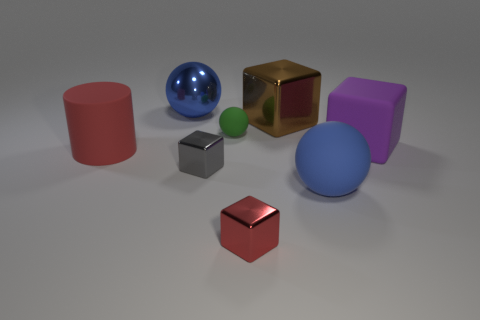Is there any other thing of the same color as the big rubber sphere?
Your response must be concise. Yes. Does the big rubber thing on the left side of the green sphere have the same color as the small thing in front of the blue matte sphere?
Give a very brief answer. Yes. What is the shape of the matte thing that is the same color as the shiny sphere?
Offer a very short reply. Sphere. What number of things are either tiny green cubes or large metal things that are right of the small gray metallic cube?
Offer a terse response. 1. Are there more tiny green rubber things than big brown matte cylinders?
Keep it short and to the point. Yes. There is a big thing on the left side of the large metallic ball; what is its shape?
Your response must be concise. Cylinder. What number of purple things have the same shape as the tiny red object?
Make the answer very short. 1. How big is the blue ball in front of the small metal object that is behind the big rubber ball?
Give a very brief answer. Large. What number of red things are either big metallic balls or matte cylinders?
Offer a very short reply. 1. Are there fewer tiny red blocks behind the big blue rubber ball than shiny cubes on the left side of the red block?
Give a very brief answer. Yes. 